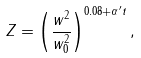Convert formula to latex. <formula><loc_0><loc_0><loc_500><loc_500>Z = \left ( \frac { w ^ { 2 } } { w _ { 0 } ^ { 2 } } \right ) ^ { 0 . 0 8 + { \alpha } ^ { \prime } t } ,</formula> 